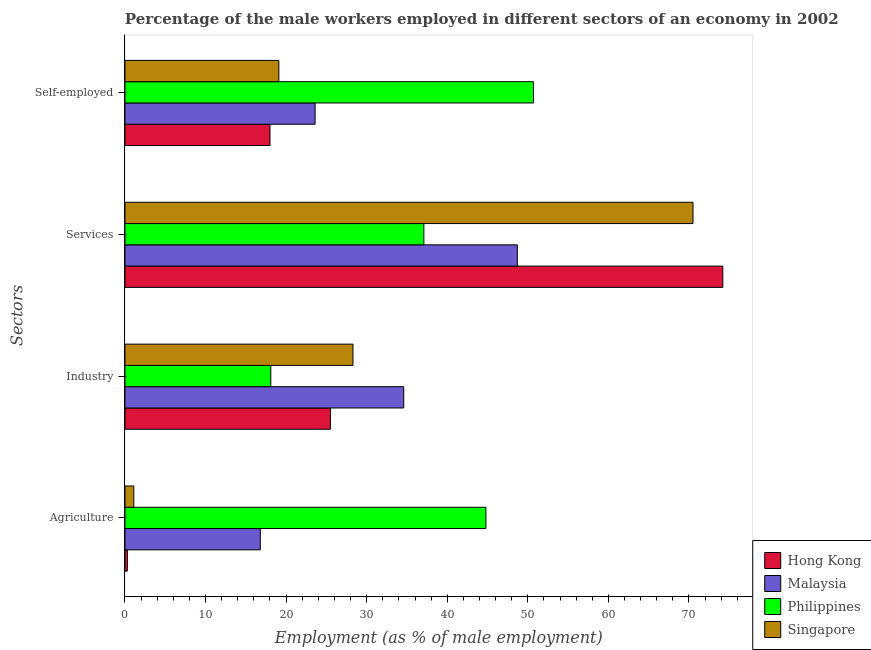How many different coloured bars are there?
Your answer should be very brief. 4. Are the number of bars per tick equal to the number of legend labels?
Your answer should be compact. Yes. Are the number of bars on each tick of the Y-axis equal?
Offer a very short reply. Yes. How many bars are there on the 2nd tick from the top?
Your answer should be compact. 4. How many bars are there on the 1st tick from the bottom?
Make the answer very short. 4. What is the label of the 3rd group of bars from the top?
Make the answer very short. Industry. What is the percentage of male workers in agriculture in Singapore?
Your answer should be very brief. 1.1. Across all countries, what is the maximum percentage of male workers in agriculture?
Keep it short and to the point. 44.8. Across all countries, what is the minimum percentage of male workers in industry?
Ensure brevity in your answer.  18.1. In which country was the percentage of self employed male workers minimum?
Keep it short and to the point. Hong Kong. What is the total percentage of male workers in industry in the graph?
Give a very brief answer. 106.5. What is the difference between the percentage of self employed male workers in Hong Kong and that in Singapore?
Give a very brief answer. -1.1. What is the difference between the percentage of male workers in industry in Malaysia and the percentage of male workers in agriculture in Philippines?
Keep it short and to the point. -10.2. What is the average percentage of male workers in services per country?
Your answer should be very brief. 57.62. What is the difference between the percentage of male workers in services and percentage of male workers in industry in Hong Kong?
Give a very brief answer. 48.7. In how many countries, is the percentage of male workers in agriculture greater than 56 %?
Keep it short and to the point. 0. What is the ratio of the percentage of male workers in industry in Philippines to that in Singapore?
Your response must be concise. 0.64. Is the percentage of male workers in services in Hong Kong less than that in Philippines?
Ensure brevity in your answer.  No. Is the difference between the percentage of male workers in industry in Hong Kong and Philippines greater than the difference between the percentage of self employed male workers in Hong Kong and Philippines?
Your response must be concise. Yes. What is the difference between the highest and the second highest percentage of self employed male workers?
Your answer should be compact. 27.1. What is the difference between the highest and the lowest percentage of male workers in industry?
Provide a short and direct response. 16.5. In how many countries, is the percentage of male workers in agriculture greater than the average percentage of male workers in agriculture taken over all countries?
Make the answer very short. 2. Is the sum of the percentage of male workers in industry in Singapore and Philippines greater than the maximum percentage of self employed male workers across all countries?
Make the answer very short. No. Is it the case that in every country, the sum of the percentage of male workers in services and percentage of male workers in industry is greater than the sum of percentage of male workers in agriculture and percentage of self employed male workers?
Give a very brief answer. No. What does the 3rd bar from the top in Self-employed represents?
Offer a very short reply. Malaysia. What does the 3rd bar from the bottom in Services represents?
Offer a very short reply. Philippines. Is it the case that in every country, the sum of the percentage of male workers in agriculture and percentage of male workers in industry is greater than the percentage of male workers in services?
Provide a short and direct response. No. How many bars are there?
Your answer should be very brief. 16. Are all the bars in the graph horizontal?
Keep it short and to the point. Yes. How many countries are there in the graph?
Make the answer very short. 4. How many legend labels are there?
Your answer should be compact. 4. What is the title of the graph?
Ensure brevity in your answer.  Percentage of the male workers employed in different sectors of an economy in 2002. Does "Iraq" appear as one of the legend labels in the graph?
Keep it short and to the point. No. What is the label or title of the X-axis?
Provide a short and direct response. Employment (as % of male employment). What is the label or title of the Y-axis?
Provide a succinct answer. Sectors. What is the Employment (as % of male employment) of Hong Kong in Agriculture?
Keep it short and to the point. 0.3. What is the Employment (as % of male employment) in Malaysia in Agriculture?
Give a very brief answer. 16.8. What is the Employment (as % of male employment) in Philippines in Agriculture?
Keep it short and to the point. 44.8. What is the Employment (as % of male employment) in Singapore in Agriculture?
Keep it short and to the point. 1.1. What is the Employment (as % of male employment) in Hong Kong in Industry?
Make the answer very short. 25.5. What is the Employment (as % of male employment) in Malaysia in Industry?
Your answer should be very brief. 34.6. What is the Employment (as % of male employment) of Philippines in Industry?
Your response must be concise. 18.1. What is the Employment (as % of male employment) in Singapore in Industry?
Offer a terse response. 28.3. What is the Employment (as % of male employment) in Hong Kong in Services?
Offer a terse response. 74.2. What is the Employment (as % of male employment) of Malaysia in Services?
Ensure brevity in your answer.  48.7. What is the Employment (as % of male employment) of Philippines in Services?
Provide a succinct answer. 37.1. What is the Employment (as % of male employment) in Singapore in Services?
Offer a terse response. 70.5. What is the Employment (as % of male employment) of Malaysia in Self-employed?
Keep it short and to the point. 23.6. What is the Employment (as % of male employment) of Philippines in Self-employed?
Offer a very short reply. 50.7. What is the Employment (as % of male employment) of Singapore in Self-employed?
Your answer should be very brief. 19.1. Across all Sectors, what is the maximum Employment (as % of male employment) in Hong Kong?
Your response must be concise. 74.2. Across all Sectors, what is the maximum Employment (as % of male employment) in Malaysia?
Provide a succinct answer. 48.7. Across all Sectors, what is the maximum Employment (as % of male employment) of Philippines?
Your response must be concise. 50.7. Across all Sectors, what is the maximum Employment (as % of male employment) in Singapore?
Offer a very short reply. 70.5. Across all Sectors, what is the minimum Employment (as % of male employment) in Hong Kong?
Provide a succinct answer. 0.3. Across all Sectors, what is the minimum Employment (as % of male employment) in Malaysia?
Give a very brief answer. 16.8. Across all Sectors, what is the minimum Employment (as % of male employment) in Philippines?
Keep it short and to the point. 18.1. Across all Sectors, what is the minimum Employment (as % of male employment) of Singapore?
Provide a succinct answer. 1.1. What is the total Employment (as % of male employment) of Hong Kong in the graph?
Provide a succinct answer. 118. What is the total Employment (as % of male employment) of Malaysia in the graph?
Offer a terse response. 123.7. What is the total Employment (as % of male employment) of Philippines in the graph?
Offer a terse response. 150.7. What is the total Employment (as % of male employment) of Singapore in the graph?
Provide a short and direct response. 119. What is the difference between the Employment (as % of male employment) of Hong Kong in Agriculture and that in Industry?
Offer a terse response. -25.2. What is the difference between the Employment (as % of male employment) in Malaysia in Agriculture and that in Industry?
Make the answer very short. -17.8. What is the difference between the Employment (as % of male employment) of Philippines in Agriculture and that in Industry?
Give a very brief answer. 26.7. What is the difference between the Employment (as % of male employment) of Singapore in Agriculture and that in Industry?
Offer a very short reply. -27.2. What is the difference between the Employment (as % of male employment) of Hong Kong in Agriculture and that in Services?
Your answer should be very brief. -73.9. What is the difference between the Employment (as % of male employment) in Malaysia in Agriculture and that in Services?
Your answer should be compact. -31.9. What is the difference between the Employment (as % of male employment) of Philippines in Agriculture and that in Services?
Give a very brief answer. 7.7. What is the difference between the Employment (as % of male employment) in Singapore in Agriculture and that in Services?
Provide a short and direct response. -69.4. What is the difference between the Employment (as % of male employment) in Hong Kong in Agriculture and that in Self-employed?
Keep it short and to the point. -17.7. What is the difference between the Employment (as % of male employment) of Philippines in Agriculture and that in Self-employed?
Offer a terse response. -5.9. What is the difference between the Employment (as % of male employment) in Hong Kong in Industry and that in Services?
Keep it short and to the point. -48.7. What is the difference between the Employment (as % of male employment) in Malaysia in Industry and that in Services?
Provide a short and direct response. -14.1. What is the difference between the Employment (as % of male employment) of Singapore in Industry and that in Services?
Give a very brief answer. -42.2. What is the difference between the Employment (as % of male employment) of Hong Kong in Industry and that in Self-employed?
Make the answer very short. 7.5. What is the difference between the Employment (as % of male employment) in Malaysia in Industry and that in Self-employed?
Your answer should be compact. 11. What is the difference between the Employment (as % of male employment) in Philippines in Industry and that in Self-employed?
Ensure brevity in your answer.  -32.6. What is the difference between the Employment (as % of male employment) in Singapore in Industry and that in Self-employed?
Your answer should be compact. 9.2. What is the difference between the Employment (as % of male employment) of Hong Kong in Services and that in Self-employed?
Provide a succinct answer. 56.2. What is the difference between the Employment (as % of male employment) in Malaysia in Services and that in Self-employed?
Offer a terse response. 25.1. What is the difference between the Employment (as % of male employment) in Singapore in Services and that in Self-employed?
Offer a terse response. 51.4. What is the difference between the Employment (as % of male employment) in Hong Kong in Agriculture and the Employment (as % of male employment) in Malaysia in Industry?
Your answer should be compact. -34.3. What is the difference between the Employment (as % of male employment) in Hong Kong in Agriculture and the Employment (as % of male employment) in Philippines in Industry?
Your answer should be compact. -17.8. What is the difference between the Employment (as % of male employment) in Malaysia in Agriculture and the Employment (as % of male employment) in Philippines in Industry?
Ensure brevity in your answer.  -1.3. What is the difference between the Employment (as % of male employment) of Malaysia in Agriculture and the Employment (as % of male employment) of Singapore in Industry?
Make the answer very short. -11.5. What is the difference between the Employment (as % of male employment) of Philippines in Agriculture and the Employment (as % of male employment) of Singapore in Industry?
Your answer should be very brief. 16.5. What is the difference between the Employment (as % of male employment) of Hong Kong in Agriculture and the Employment (as % of male employment) of Malaysia in Services?
Make the answer very short. -48.4. What is the difference between the Employment (as % of male employment) of Hong Kong in Agriculture and the Employment (as % of male employment) of Philippines in Services?
Ensure brevity in your answer.  -36.8. What is the difference between the Employment (as % of male employment) in Hong Kong in Agriculture and the Employment (as % of male employment) in Singapore in Services?
Keep it short and to the point. -70.2. What is the difference between the Employment (as % of male employment) in Malaysia in Agriculture and the Employment (as % of male employment) in Philippines in Services?
Your answer should be very brief. -20.3. What is the difference between the Employment (as % of male employment) in Malaysia in Agriculture and the Employment (as % of male employment) in Singapore in Services?
Give a very brief answer. -53.7. What is the difference between the Employment (as % of male employment) in Philippines in Agriculture and the Employment (as % of male employment) in Singapore in Services?
Your answer should be compact. -25.7. What is the difference between the Employment (as % of male employment) in Hong Kong in Agriculture and the Employment (as % of male employment) in Malaysia in Self-employed?
Make the answer very short. -23.3. What is the difference between the Employment (as % of male employment) of Hong Kong in Agriculture and the Employment (as % of male employment) of Philippines in Self-employed?
Ensure brevity in your answer.  -50.4. What is the difference between the Employment (as % of male employment) in Hong Kong in Agriculture and the Employment (as % of male employment) in Singapore in Self-employed?
Provide a succinct answer. -18.8. What is the difference between the Employment (as % of male employment) in Malaysia in Agriculture and the Employment (as % of male employment) in Philippines in Self-employed?
Keep it short and to the point. -33.9. What is the difference between the Employment (as % of male employment) of Philippines in Agriculture and the Employment (as % of male employment) of Singapore in Self-employed?
Offer a very short reply. 25.7. What is the difference between the Employment (as % of male employment) in Hong Kong in Industry and the Employment (as % of male employment) in Malaysia in Services?
Give a very brief answer. -23.2. What is the difference between the Employment (as % of male employment) of Hong Kong in Industry and the Employment (as % of male employment) of Philippines in Services?
Give a very brief answer. -11.6. What is the difference between the Employment (as % of male employment) in Hong Kong in Industry and the Employment (as % of male employment) in Singapore in Services?
Provide a succinct answer. -45. What is the difference between the Employment (as % of male employment) in Malaysia in Industry and the Employment (as % of male employment) in Philippines in Services?
Make the answer very short. -2.5. What is the difference between the Employment (as % of male employment) of Malaysia in Industry and the Employment (as % of male employment) of Singapore in Services?
Provide a short and direct response. -35.9. What is the difference between the Employment (as % of male employment) in Philippines in Industry and the Employment (as % of male employment) in Singapore in Services?
Your response must be concise. -52.4. What is the difference between the Employment (as % of male employment) in Hong Kong in Industry and the Employment (as % of male employment) in Malaysia in Self-employed?
Your answer should be compact. 1.9. What is the difference between the Employment (as % of male employment) of Hong Kong in Industry and the Employment (as % of male employment) of Philippines in Self-employed?
Offer a terse response. -25.2. What is the difference between the Employment (as % of male employment) of Malaysia in Industry and the Employment (as % of male employment) of Philippines in Self-employed?
Keep it short and to the point. -16.1. What is the difference between the Employment (as % of male employment) of Malaysia in Industry and the Employment (as % of male employment) of Singapore in Self-employed?
Ensure brevity in your answer.  15.5. What is the difference between the Employment (as % of male employment) of Hong Kong in Services and the Employment (as % of male employment) of Malaysia in Self-employed?
Your answer should be compact. 50.6. What is the difference between the Employment (as % of male employment) in Hong Kong in Services and the Employment (as % of male employment) in Singapore in Self-employed?
Keep it short and to the point. 55.1. What is the difference between the Employment (as % of male employment) of Malaysia in Services and the Employment (as % of male employment) of Singapore in Self-employed?
Provide a short and direct response. 29.6. What is the difference between the Employment (as % of male employment) of Philippines in Services and the Employment (as % of male employment) of Singapore in Self-employed?
Offer a terse response. 18. What is the average Employment (as % of male employment) of Hong Kong per Sectors?
Offer a terse response. 29.5. What is the average Employment (as % of male employment) in Malaysia per Sectors?
Keep it short and to the point. 30.93. What is the average Employment (as % of male employment) in Philippines per Sectors?
Offer a terse response. 37.67. What is the average Employment (as % of male employment) in Singapore per Sectors?
Your answer should be very brief. 29.75. What is the difference between the Employment (as % of male employment) of Hong Kong and Employment (as % of male employment) of Malaysia in Agriculture?
Your answer should be very brief. -16.5. What is the difference between the Employment (as % of male employment) of Hong Kong and Employment (as % of male employment) of Philippines in Agriculture?
Keep it short and to the point. -44.5. What is the difference between the Employment (as % of male employment) of Malaysia and Employment (as % of male employment) of Singapore in Agriculture?
Keep it short and to the point. 15.7. What is the difference between the Employment (as % of male employment) in Philippines and Employment (as % of male employment) in Singapore in Agriculture?
Provide a short and direct response. 43.7. What is the difference between the Employment (as % of male employment) of Hong Kong and Employment (as % of male employment) of Malaysia in Industry?
Provide a succinct answer. -9.1. What is the difference between the Employment (as % of male employment) in Hong Kong and Employment (as % of male employment) in Malaysia in Services?
Provide a short and direct response. 25.5. What is the difference between the Employment (as % of male employment) in Hong Kong and Employment (as % of male employment) in Philippines in Services?
Provide a succinct answer. 37.1. What is the difference between the Employment (as % of male employment) in Hong Kong and Employment (as % of male employment) in Singapore in Services?
Your response must be concise. 3.7. What is the difference between the Employment (as % of male employment) of Malaysia and Employment (as % of male employment) of Philippines in Services?
Your answer should be compact. 11.6. What is the difference between the Employment (as % of male employment) in Malaysia and Employment (as % of male employment) in Singapore in Services?
Give a very brief answer. -21.8. What is the difference between the Employment (as % of male employment) of Philippines and Employment (as % of male employment) of Singapore in Services?
Offer a terse response. -33.4. What is the difference between the Employment (as % of male employment) of Hong Kong and Employment (as % of male employment) of Philippines in Self-employed?
Ensure brevity in your answer.  -32.7. What is the difference between the Employment (as % of male employment) in Hong Kong and Employment (as % of male employment) in Singapore in Self-employed?
Offer a very short reply. -1.1. What is the difference between the Employment (as % of male employment) in Malaysia and Employment (as % of male employment) in Philippines in Self-employed?
Offer a terse response. -27.1. What is the difference between the Employment (as % of male employment) of Malaysia and Employment (as % of male employment) of Singapore in Self-employed?
Give a very brief answer. 4.5. What is the difference between the Employment (as % of male employment) in Philippines and Employment (as % of male employment) in Singapore in Self-employed?
Keep it short and to the point. 31.6. What is the ratio of the Employment (as % of male employment) of Hong Kong in Agriculture to that in Industry?
Your answer should be very brief. 0.01. What is the ratio of the Employment (as % of male employment) in Malaysia in Agriculture to that in Industry?
Give a very brief answer. 0.49. What is the ratio of the Employment (as % of male employment) in Philippines in Agriculture to that in Industry?
Give a very brief answer. 2.48. What is the ratio of the Employment (as % of male employment) of Singapore in Agriculture to that in Industry?
Your answer should be compact. 0.04. What is the ratio of the Employment (as % of male employment) in Hong Kong in Agriculture to that in Services?
Offer a terse response. 0. What is the ratio of the Employment (as % of male employment) in Malaysia in Agriculture to that in Services?
Offer a terse response. 0.34. What is the ratio of the Employment (as % of male employment) of Philippines in Agriculture to that in Services?
Provide a short and direct response. 1.21. What is the ratio of the Employment (as % of male employment) in Singapore in Agriculture to that in Services?
Make the answer very short. 0.02. What is the ratio of the Employment (as % of male employment) in Hong Kong in Agriculture to that in Self-employed?
Make the answer very short. 0.02. What is the ratio of the Employment (as % of male employment) in Malaysia in Agriculture to that in Self-employed?
Give a very brief answer. 0.71. What is the ratio of the Employment (as % of male employment) of Philippines in Agriculture to that in Self-employed?
Offer a terse response. 0.88. What is the ratio of the Employment (as % of male employment) of Singapore in Agriculture to that in Self-employed?
Offer a very short reply. 0.06. What is the ratio of the Employment (as % of male employment) of Hong Kong in Industry to that in Services?
Offer a very short reply. 0.34. What is the ratio of the Employment (as % of male employment) of Malaysia in Industry to that in Services?
Make the answer very short. 0.71. What is the ratio of the Employment (as % of male employment) in Philippines in Industry to that in Services?
Make the answer very short. 0.49. What is the ratio of the Employment (as % of male employment) of Singapore in Industry to that in Services?
Your answer should be compact. 0.4. What is the ratio of the Employment (as % of male employment) of Hong Kong in Industry to that in Self-employed?
Offer a terse response. 1.42. What is the ratio of the Employment (as % of male employment) in Malaysia in Industry to that in Self-employed?
Give a very brief answer. 1.47. What is the ratio of the Employment (as % of male employment) in Philippines in Industry to that in Self-employed?
Your answer should be very brief. 0.36. What is the ratio of the Employment (as % of male employment) in Singapore in Industry to that in Self-employed?
Make the answer very short. 1.48. What is the ratio of the Employment (as % of male employment) in Hong Kong in Services to that in Self-employed?
Your answer should be compact. 4.12. What is the ratio of the Employment (as % of male employment) of Malaysia in Services to that in Self-employed?
Ensure brevity in your answer.  2.06. What is the ratio of the Employment (as % of male employment) of Philippines in Services to that in Self-employed?
Make the answer very short. 0.73. What is the ratio of the Employment (as % of male employment) in Singapore in Services to that in Self-employed?
Your response must be concise. 3.69. What is the difference between the highest and the second highest Employment (as % of male employment) of Hong Kong?
Provide a short and direct response. 48.7. What is the difference between the highest and the second highest Employment (as % of male employment) in Malaysia?
Keep it short and to the point. 14.1. What is the difference between the highest and the second highest Employment (as % of male employment) in Singapore?
Give a very brief answer. 42.2. What is the difference between the highest and the lowest Employment (as % of male employment) of Hong Kong?
Offer a very short reply. 73.9. What is the difference between the highest and the lowest Employment (as % of male employment) in Malaysia?
Keep it short and to the point. 31.9. What is the difference between the highest and the lowest Employment (as % of male employment) of Philippines?
Your answer should be very brief. 32.6. What is the difference between the highest and the lowest Employment (as % of male employment) in Singapore?
Your answer should be very brief. 69.4. 